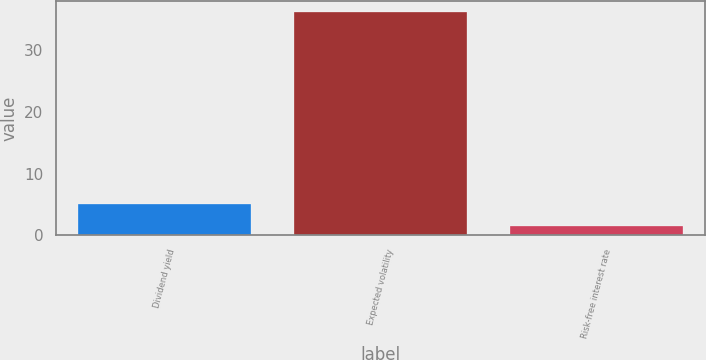Convert chart. <chart><loc_0><loc_0><loc_500><loc_500><bar_chart><fcel>Dividend yield<fcel>Expected volatility<fcel>Risk-free interest rate<nl><fcel>5.03<fcel>36.2<fcel>1.57<nl></chart> 